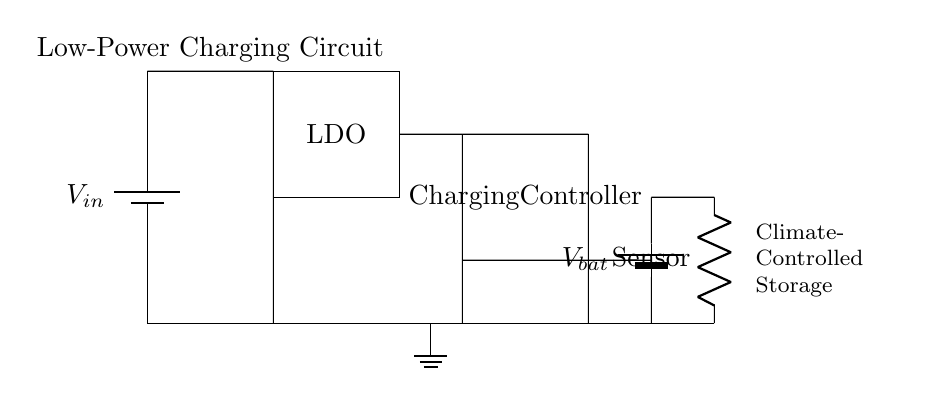What is the input voltage source in the circuit? The diagram labels the voltage source as V_in, indicating it is the input voltage for the circuit.
Answer: V_in What type of voltage regulator is used in this circuit? The circuit shows a rectangle labeled "LDO," which stands for Low Dropout Regulator, indicating the type of voltage regulator present.
Answer: LDO What is the purpose of the charging controller in the circuit? The rectangle labeled "Charging Controller" indicates that its purpose is to manage the charging process for the battery, optimizing energy transfer to ensure proper charging.
Answer: Manage charging What is the voltage of the battery in the circuit? The diagram includes a battery labeled V_bat, which denotes the voltage level of the battery component within the circuit.
Answer: V_bat How is the sensor connected in the circuit? From the diagram, the sensor is connected in series with the battery, receiving power from it while also being part of the circuit that operates with the stored energy.
Answer: In series What indicates that this circuit is designed for low power consumption? The term "Low-Power Charging Circuit" is noted above the diagram, implying that its design and components are optimized for low power usage, suitable for delicate sensors.
Answer: Low-Power What is the overall function of this circuit in a climate-controlled storage? The circuit is designed to provide a stable and controlled charging environment to preserve delicate electronic sensors, ensuring they remain operational even in sensitive storage conditions.
Answer: Preserve sensors 